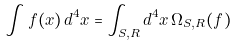<formula> <loc_0><loc_0><loc_500><loc_500>\int f ( x ) \, d ^ { 4 } x = \int _ { S , R } d ^ { 4 } x \, \Omega _ { S , R } ( f )</formula> 